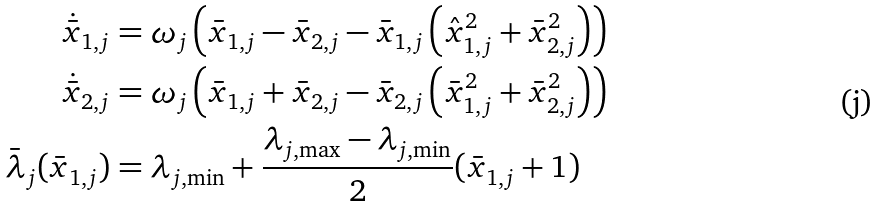Convert formula to latex. <formula><loc_0><loc_0><loc_500><loc_500>\dot { \bar { x } } _ { 1 , j } & = \omega _ { j } \left ( \bar { x } _ { 1 , j } - \bar { x } _ { 2 , j } - \bar { x } _ { 1 , j } \left ( \hat { x } _ { 1 , j } ^ { 2 } + \bar { x } _ { 2 , j } ^ { 2 } \right ) \right ) \\ \dot { \bar { x } } _ { 2 , j } & = \omega _ { j } \left ( \bar { x } _ { 1 , j } + \bar { x } _ { 2 , j } - \bar { x } _ { 2 , j } \left ( \bar { x } _ { 1 , j } ^ { 2 } + \bar { x } _ { 2 , j } ^ { 2 } \right ) \right ) \\ \bar { \lambda } _ { j } ( \bar { x } _ { 1 , j } ) & = \lambda _ { j , \min } + \frac { \lambda _ { j , \max } - \lambda _ { j , \min } } { 2 } ( \bar { x } _ { 1 , j } + 1 )</formula> 